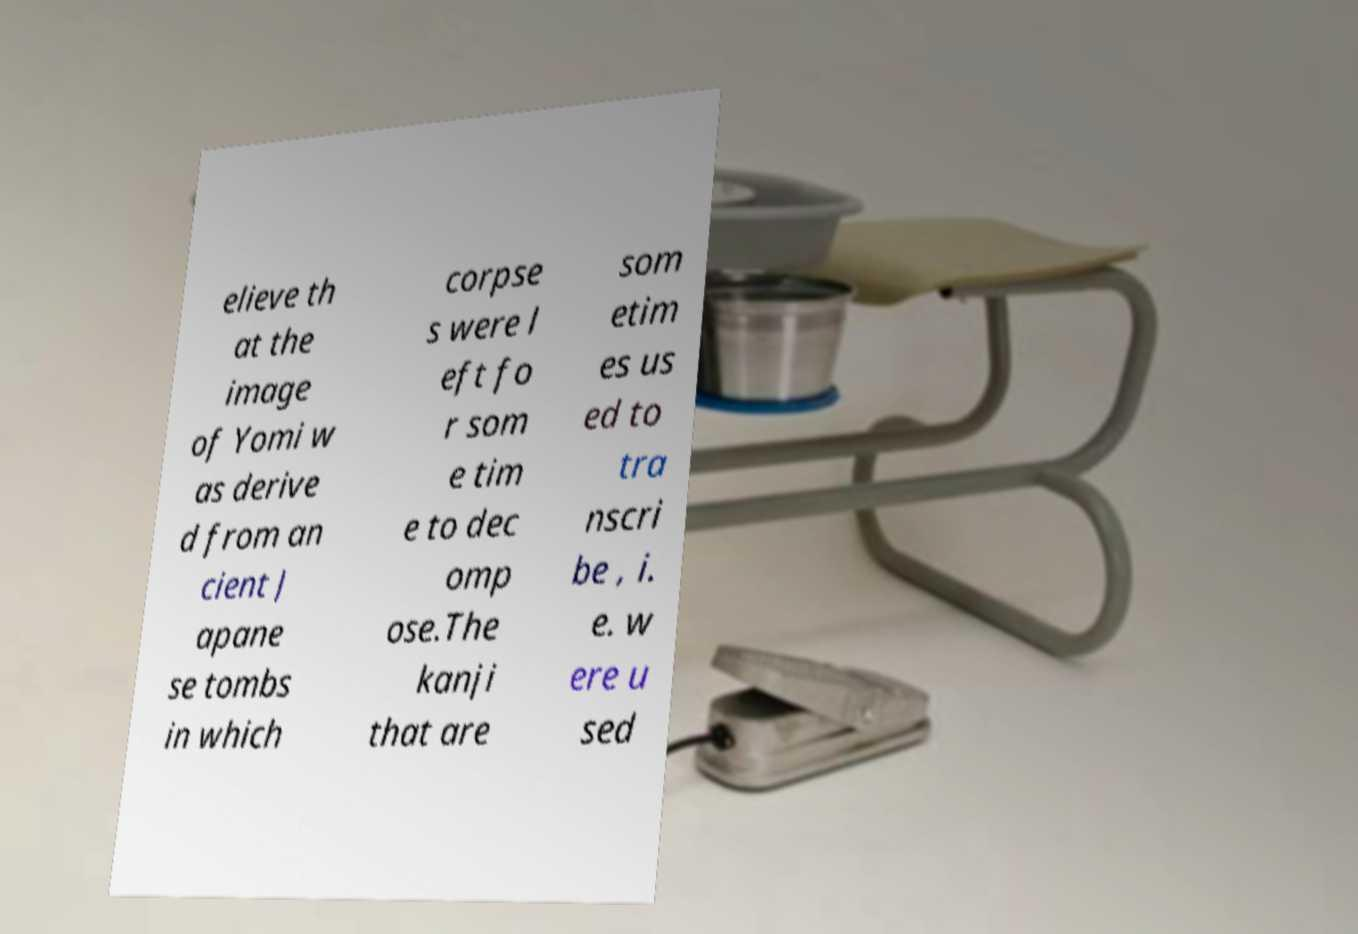Could you assist in decoding the text presented in this image and type it out clearly? elieve th at the image of Yomi w as derive d from an cient J apane se tombs in which corpse s were l eft fo r som e tim e to dec omp ose.The kanji that are som etim es us ed to tra nscri be , i. e. w ere u sed 